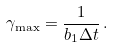Convert formula to latex. <formula><loc_0><loc_0><loc_500><loc_500>\gamma _ { \max } = \frac { 1 } { b _ { 1 } \Delta t } \, .</formula> 